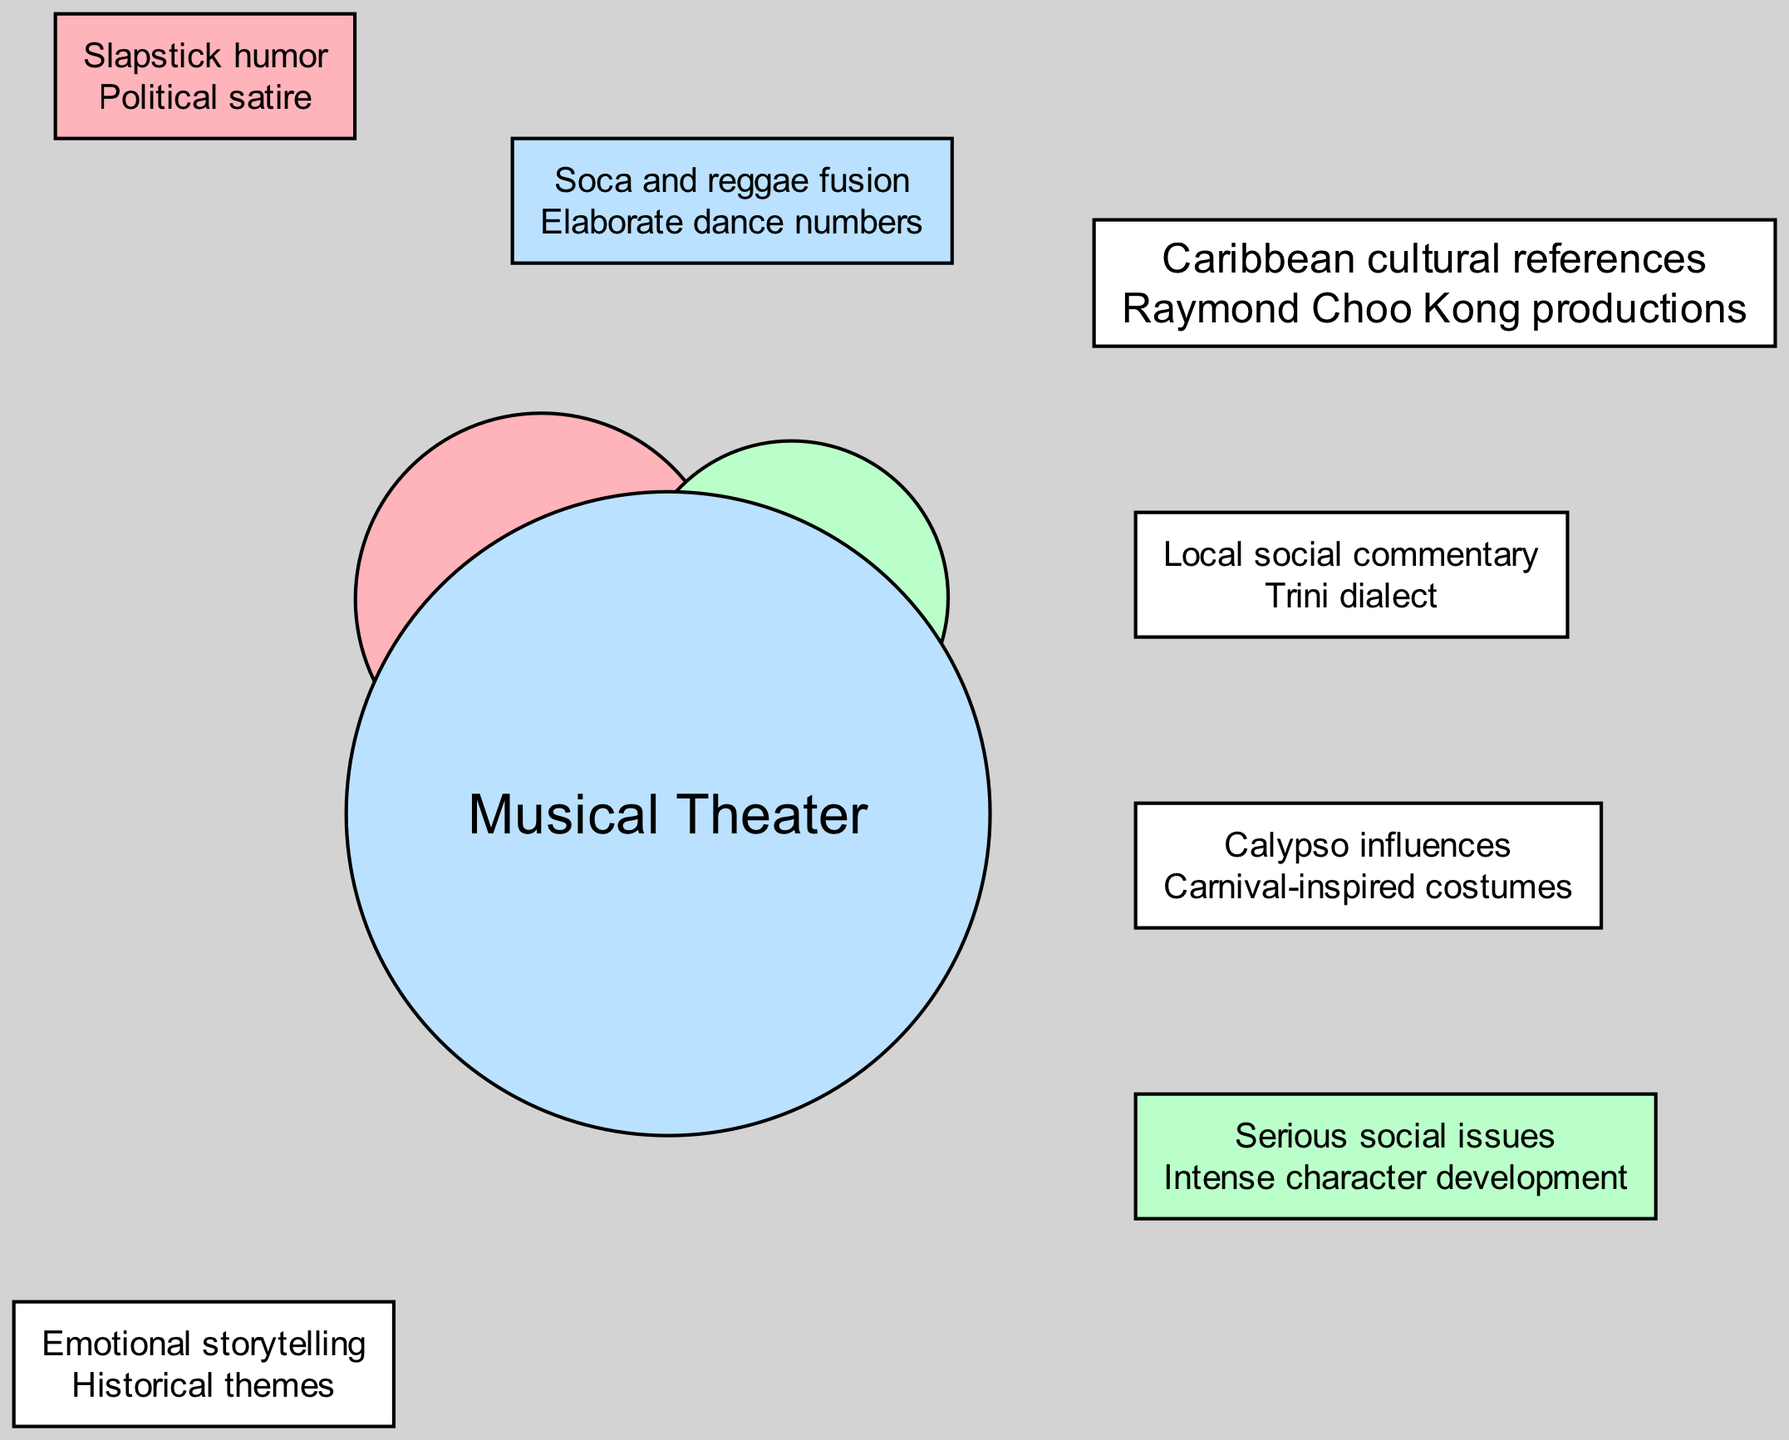What unique element is associated with Comedy? The unique elements listed in the diagram specifically for Comedy are "Slapstick humor" and "Political satire." Therefore, one of the unique elements is "Slapstick humor."
Answer: Slapstick humor What shared element do all genres have? The shared elements for all the genres include "Caribbean cultural references" and "Raymond Choo Kong productions." Thus, one shared element is "Caribbean cultural references."
Answer: Caribbean cultural references How many unique elements are listed for Musical Theater? The diagram shows two unique elements for Musical Theater: "Soca and reggae fusion" and "Elaborate dance numbers." Therefore, the total count is two.
Answer: 2 Which two genres share the element "Calypso influences"? The element "Calypso influences" is listed under the shared elements for the genres Comedy and Musical Theater. These two genres are thus the answer.
Answer: Comedy and Musical Theater What is the unique element of Drama that deals with its themes? The unique element related to themes in Drama is "Serious social issues." This focuses on the themes addressed in Dramatic productions.
Answer: Serious social issues Which genre is characterized by "Elaborate dance numbers"? "Elaborate dance numbers" is identified as a unique element of the genre Musical Theater. Therefore, this genre is the answer.
Answer: Musical Theater What are the shared elements of Comedy and Drama? The shared elements between Comedy and Drama are "Local social commentary" and "Trini dialect." Both genres share these elements.
Answer: Local social commentary, Trini dialect Which genre includes "Intense character development" as a unique element? The phrase "Intense character development" is listed as a unique element for the genre Drama. Thus, Drama is the genre that includes it.
Answer: Drama How many genres are compared in this diagram? The diagram shows three genres: Comedy, Drama, and Musical Theater. Hence, the total number of genres compared is three.
Answer: 3 